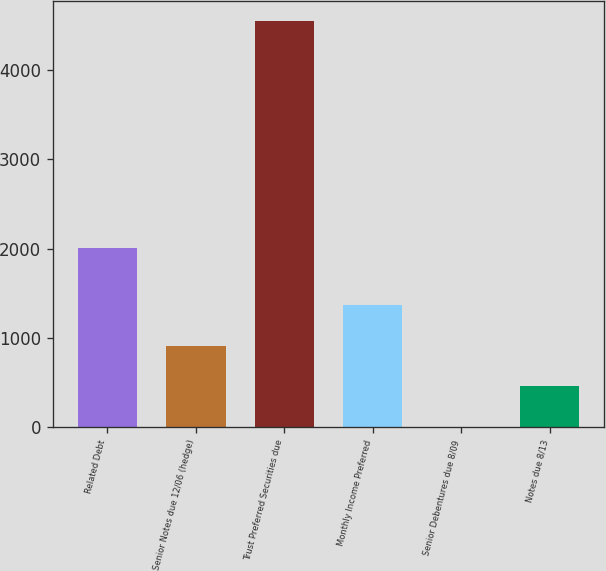Convert chart to OTSL. <chart><loc_0><loc_0><loc_500><loc_500><bar_chart><fcel>Related Debt<fcel>Senior Notes due 12/06 (hedge)<fcel>Trust Preferred Securities due<fcel>Monthly Income Preferred<fcel>Senior Debentures due 8/09<fcel>Notes due 8/13<nl><fcel>2006<fcel>909.72<fcel>4548<fcel>1364.51<fcel>0.14<fcel>454.93<nl></chart> 